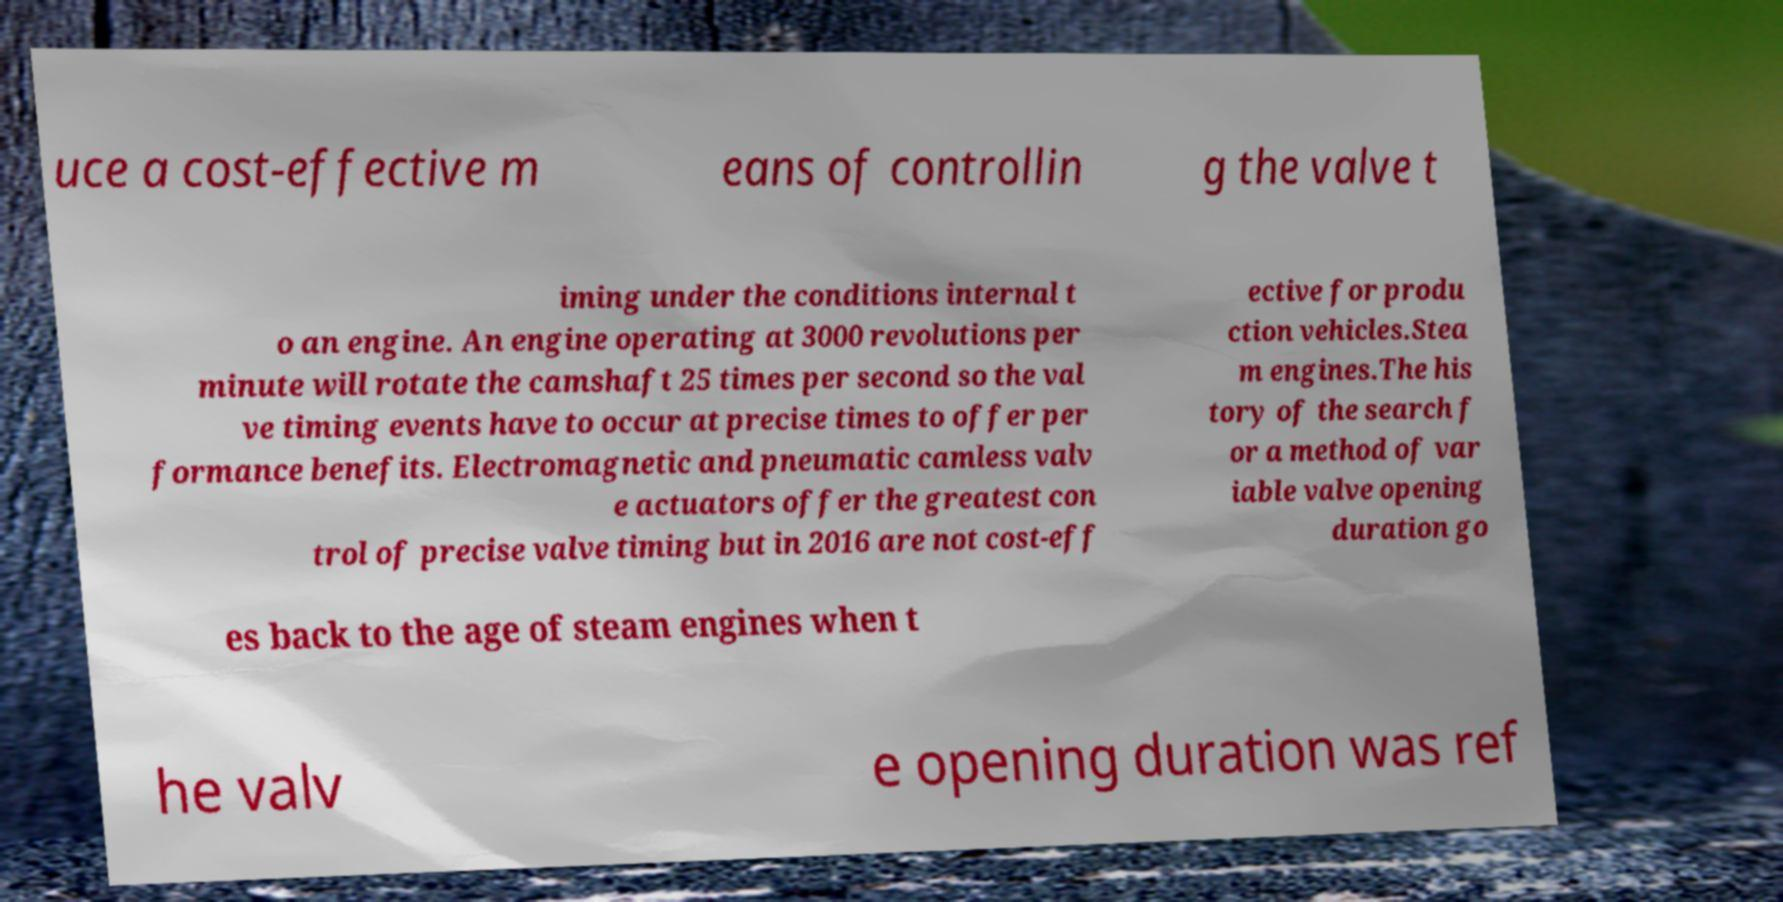There's text embedded in this image that I need extracted. Can you transcribe it verbatim? uce a cost-effective m eans of controllin g the valve t iming under the conditions internal t o an engine. An engine operating at 3000 revolutions per minute will rotate the camshaft 25 times per second so the val ve timing events have to occur at precise times to offer per formance benefits. Electromagnetic and pneumatic camless valv e actuators offer the greatest con trol of precise valve timing but in 2016 are not cost-eff ective for produ ction vehicles.Stea m engines.The his tory of the search f or a method of var iable valve opening duration go es back to the age of steam engines when t he valv e opening duration was ref 